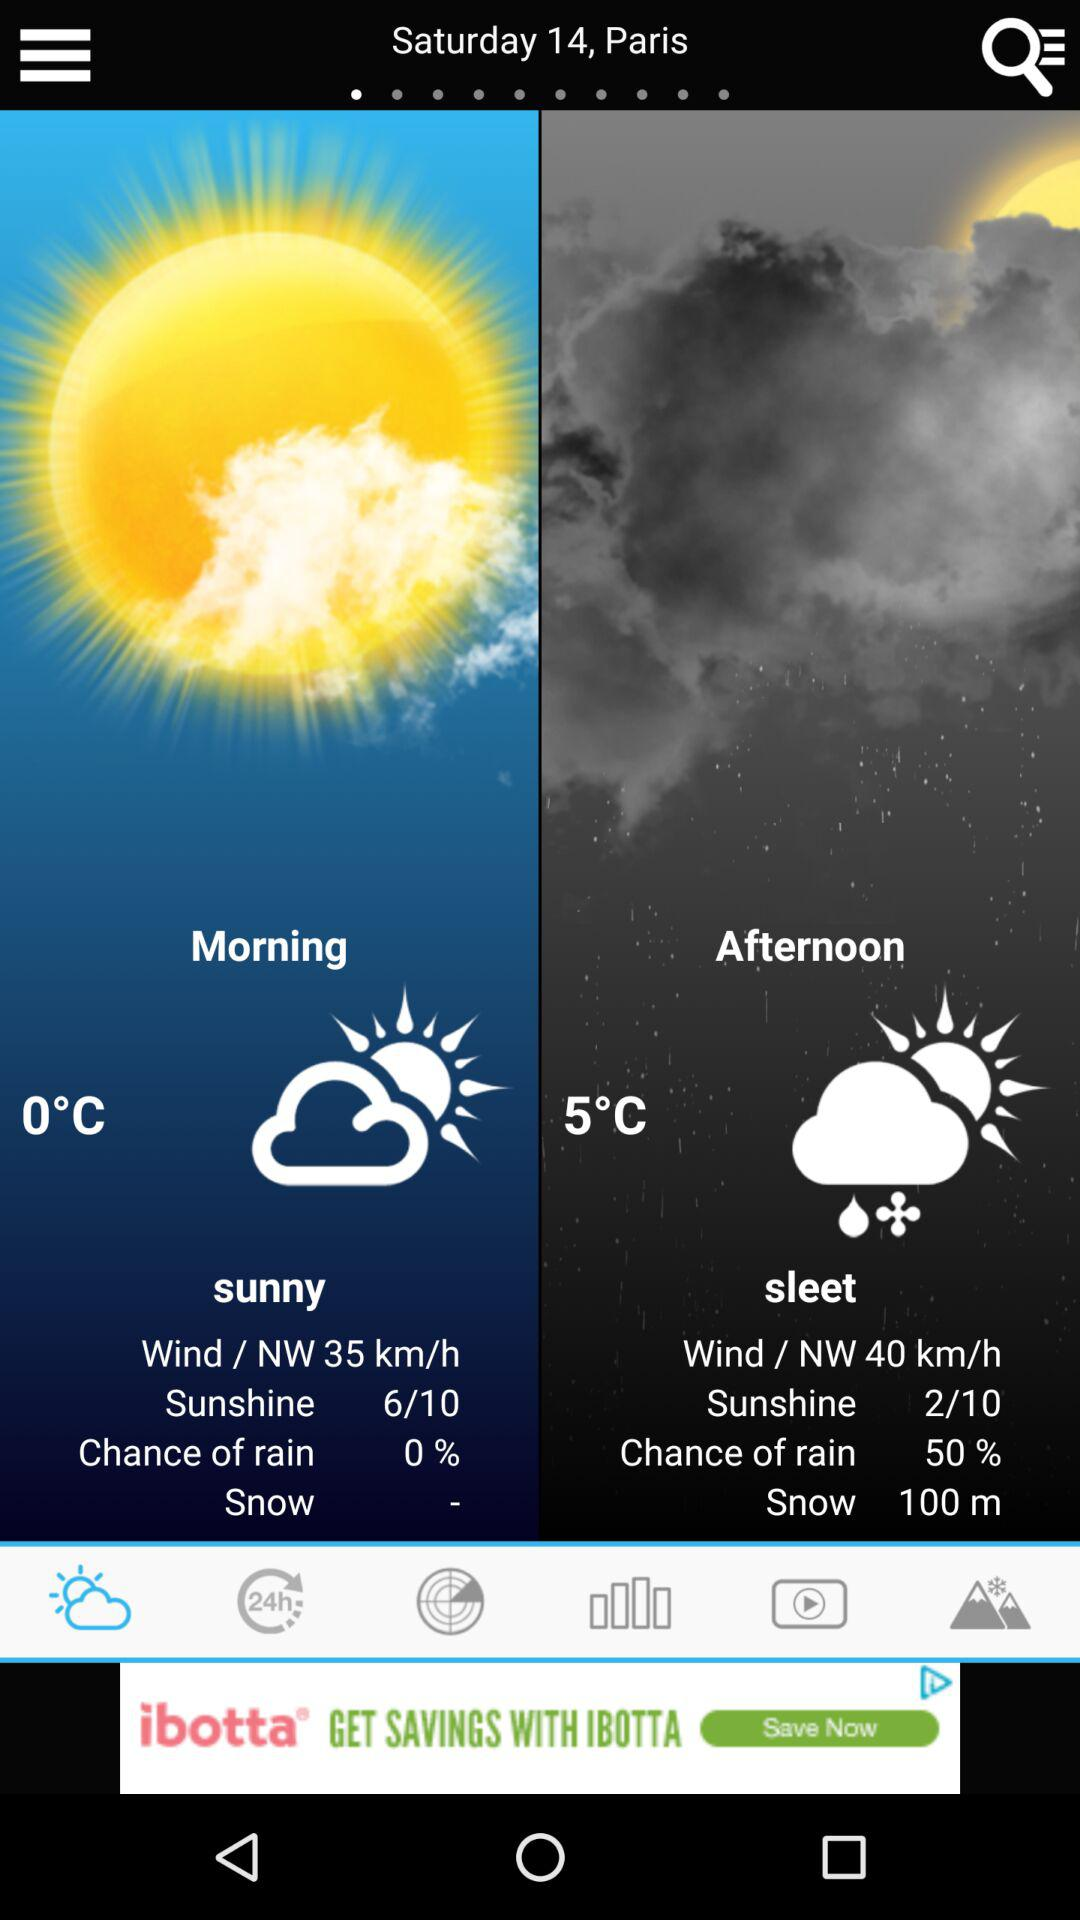What is the date? The date is Saturday, the 14th. 